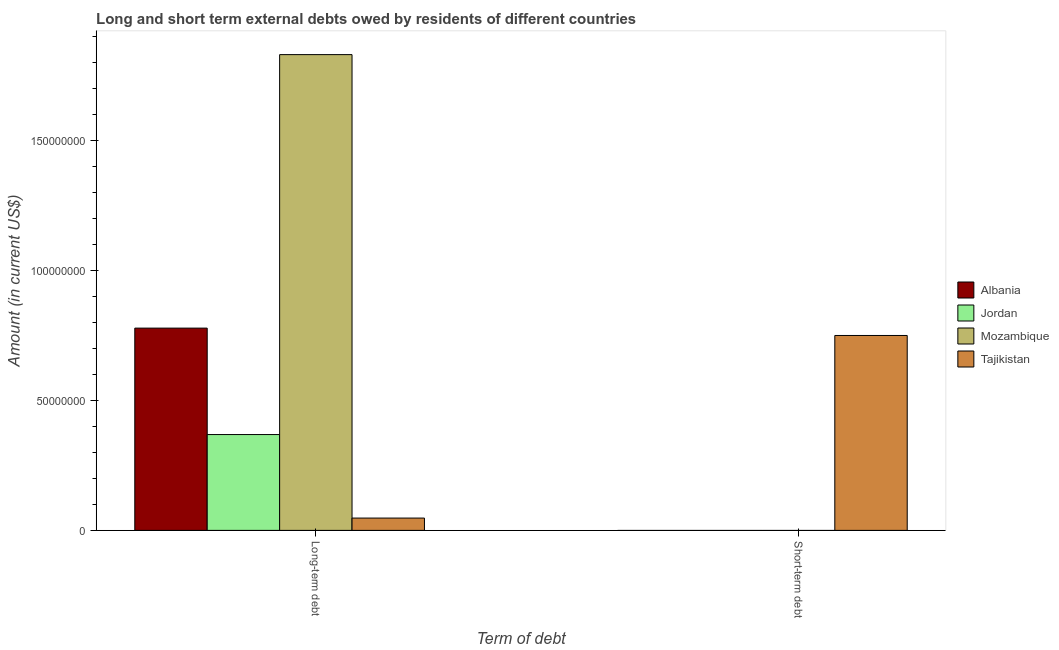How many different coloured bars are there?
Your answer should be very brief. 4. What is the label of the 1st group of bars from the left?
Provide a short and direct response. Long-term debt. What is the long-term debts owed by residents in Albania?
Make the answer very short. 7.78e+07. Across all countries, what is the maximum long-term debts owed by residents?
Provide a short and direct response. 1.83e+08. Across all countries, what is the minimum long-term debts owed by residents?
Offer a very short reply. 4.74e+06. In which country was the long-term debts owed by residents maximum?
Your response must be concise. Mozambique. What is the total long-term debts owed by residents in the graph?
Keep it short and to the point. 3.03e+08. What is the difference between the long-term debts owed by residents in Jordan and that in Tajikistan?
Make the answer very short. 3.21e+07. What is the difference between the long-term debts owed by residents in Jordan and the short-term debts owed by residents in Mozambique?
Provide a short and direct response. 3.69e+07. What is the average short-term debts owed by residents per country?
Keep it short and to the point. 1.88e+07. What is the difference between the short-term debts owed by residents and long-term debts owed by residents in Tajikistan?
Your answer should be compact. 7.03e+07. What is the ratio of the long-term debts owed by residents in Albania to that in Jordan?
Your response must be concise. 2.11. Are all the bars in the graph horizontal?
Keep it short and to the point. No. How many countries are there in the graph?
Give a very brief answer. 4. Does the graph contain grids?
Offer a terse response. No. How many legend labels are there?
Ensure brevity in your answer.  4. How are the legend labels stacked?
Your answer should be compact. Vertical. What is the title of the graph?
Provide a short and direct response. Long and short term external debts owed by residents of different countries. What is the label or title of the X-axis?
Ensure brevity in your answer.  Term of debt. What is the label or title of the Y-axis?
Give a very brief answer. Amount (in current US$). What is the Amount (in current US$) of Albania in Long-term debt?
Your answer should be compact. 7.78e+07. What is the Amount (in current US$) of Jordan in Long-term debt?
Your answer should be very brief. 3.69e+07. What is the Amount (in current US$) of Mozambique in Long-term debt?
Make the answer very short. 1.83e+08. What is the Amount (in current US$) of Tajikistan in Long-term debt?
Ensure brevity in your answer.  4.74e+06. What is the Amount (in current US$) of Albania in Short-term debt?
Offer a terse response. 0. What is the Amount (in current US$) of Jordan in Short-term debt?
Your response must be concise. 0. What is the Amount (in current US$) of Mozambique in Short-term debt?
Ensure brevity in your answer.  0. What is the Amount (in current US$) in Tajikistan in Short-term debt?
Your response must be concise. 7.50e+07. Across all Term of debt, what is the maximum Amount (in current US$) in Albania?
Provide a succinct answer. 7.78e+07. Across all Term of debt, what is the maximum Amount (in current US$) in Jordan?
Your answer should be very brief. 3.69e+07. Across all Term of debt, what is the maximum Amount (in current US$) of Mozambique?
Your response must be concise. 1.83e+08. Across all Term of debt, what is the maximum Amount (in current US$) of Tajikistan?
Give a very brief answer. 7.50e+07. Across all Term of debt, what is the minimum Amount (in current US$) of Mozambique?
Keep it short and to the point. 0. Across all Term of debt, what is the minimum Amount (in current US$) in Tajikistan?
Your answer should be very brief. 4.74e+06. What is the total Amount (in current US$) of Albania in the graph?
Make the answer very short. 7.78e+07. What is the total Amount (in current US$) of Jordan in the graph?
Provide a succinct answer. 3.69e+07. What is the total Amount (in current US$) in Mozambique in the graph?
Your response must be concise. 1.83e+08. What is the total Amount (in current US$) of Tajikistan in the graph?
Your response must be concise. 7.97e+07. What is the difference between the Amount (in current US$) in Tajikistan in Long-term debt and that in Short-term debt?
Offer a terse response. -7.03e+07. What is the difference between the Amount (in current US$) of Albania in Long-term debt and the Amount (in current US$) of Tajikistan in Short-term debt?
Provide a short and direct response. 2.84e+06. What is the difference between the Amount (in current US$) in Jordan in Long-term debt and the Amount (in current US$) in Tajikistan in Short-term debt?
Ensure brevity in your answer.  -3.81e+07. What is the difference between the Amount (in current US$) of Mozambique in Long-term debt and the Amount (in current US$) of Tajikistan in Short-term debt?
Your answer should be very brief. 1.08e+08. What is the average Amount (in current US$) of Albania per Term of debt?
Give a very brief answer. 3.89e+07. What is the average Amount (in current US$) in Jordan per Term of debt?
Ensure brevity in your answer.  1.84e+07. What is the average Amount (in current US$) in Mozambique per Term of debt?
Give a very brief answer. 9.15e+07. What is the average Amount (in current US$) in Tajikistan per Term of debt?
Offer a very short reply. 3.99e+07. What is the difference between the Amount (in current US$) of Albania and Amount (in current US$) of Jordan in Long-term debt?
Provide a succinct answer. 4.10e+07. What is the difference between the Amount (in current US$) of Albania and Amount (in current US$) of Mozambique in Long-term debt?
Provide a succinct answer. -1.05e+08. What is the difference between the Amount (in current US$) in Albania and Amount (in current US$) in Tajikistan in Long-term debt?
Give a very brief answer. 7.31e+07. What is the difference between the Amount (in current US$) of Jordan and Amount (in current US$) of Mozambique in Long-term debt?
Provide a succinct answer. -1.46e+08. What is the difference between the Amount (in current US$) in Jordan and Amount (in current US$) in Tajikistan in Long-term debt?
Offer a terse response. 3.21e+07. What is the difference between the Amount (in current US$) in Mozambique and Amount (in current US$) in Tajikistan in Long-term debt?
Ensure brevity in your answer.  1.78e+08. What is the ratio of the Amount (in current US$) of Tajikistan in Long-term debt to that in Short-term debt?
Provide a succinct answer. 0.06. What is the difference between the highest and the second highest Amount (in current US$) of Tajikistan?
Keep it short and to the point. 7.03e+07. What is the difference between the highest and the lowest Amount (in current US$) in Albania?
Ensure brevity in your answer.  7.78e+07. What is the difference between the highest and the lowest Amount (in current US$) of Jordan?
Your answer should be compact. 3.69e+07. What is the difference between the highest and the lowest Amount (in current US$) in Mozambique?
Offer a terse response. 1.83e+08. What is the difference between the highest and the lowest Amount (in current US$) in Tajikistan?
Offer a very short reply. 7.03e+07. 